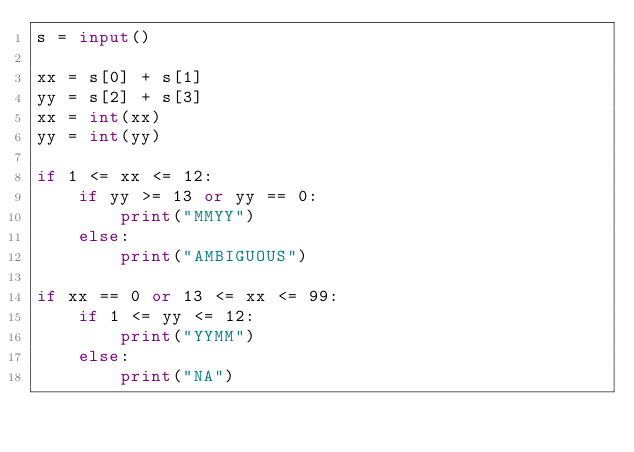<code> <loc_0><loc_0><loc_500><loc_500><_Python_>s = input()

xx = s[0] + s[1]
yy = s[2] + s[3]
xx = int(xx)
yy = int(yy)

if 1 <= xx <= 12:
    if yy >= 13 or yy == 0:
        print("MMYY")
    else:
        print("AMBIGUOUS")

if xx == 0 or 13 <= xx <= 99:
    if 1 <= yy <= 12:
        print("YYMM")
    else:
        print("NA")</code> 